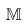Convert formula to latex. <formula><loc_0><loc_0><loc_500><loc_500>\mathbb { M }</formula> 